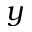<formula> <loc_0><loc_0><loc_500><loc_500>y</formula> 